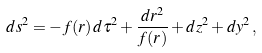Convert formula to latex. <formula><loc_0><loc_0><loc_500><loc_500>d s ^ { 2 } = - f ( r ) \, d { \tau } ^ { 2 } + \frac { d r ^ { 2 } } { f ( r ) } + d z ^ { 2 } + d y ^ { 2 } \, ,</formula> 